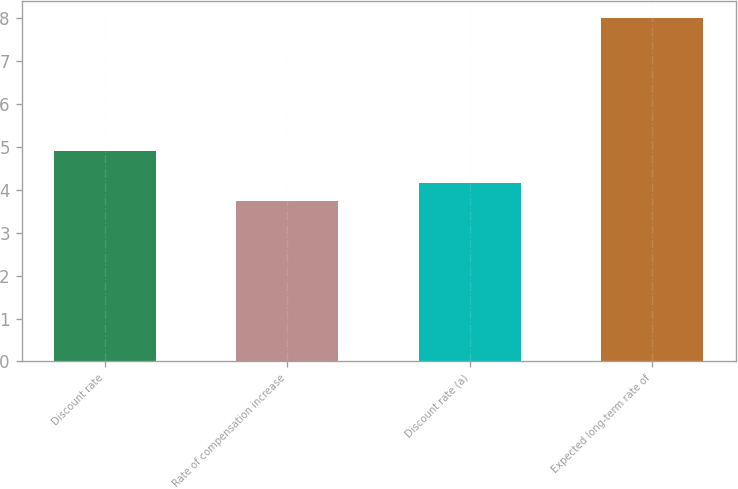Convert chart to OTSL. <chart><loc_0><loc_0><loc_500><loc_500><bar_chart><fcel>Discount rate<fcel>Rate of compensation increase<fcel>Discount rate (a)<fcel>Expected long-term rate of<nl><fcel>4.9<fcel>3.75<fcel>4.17<fcel>8<nl></chart> 